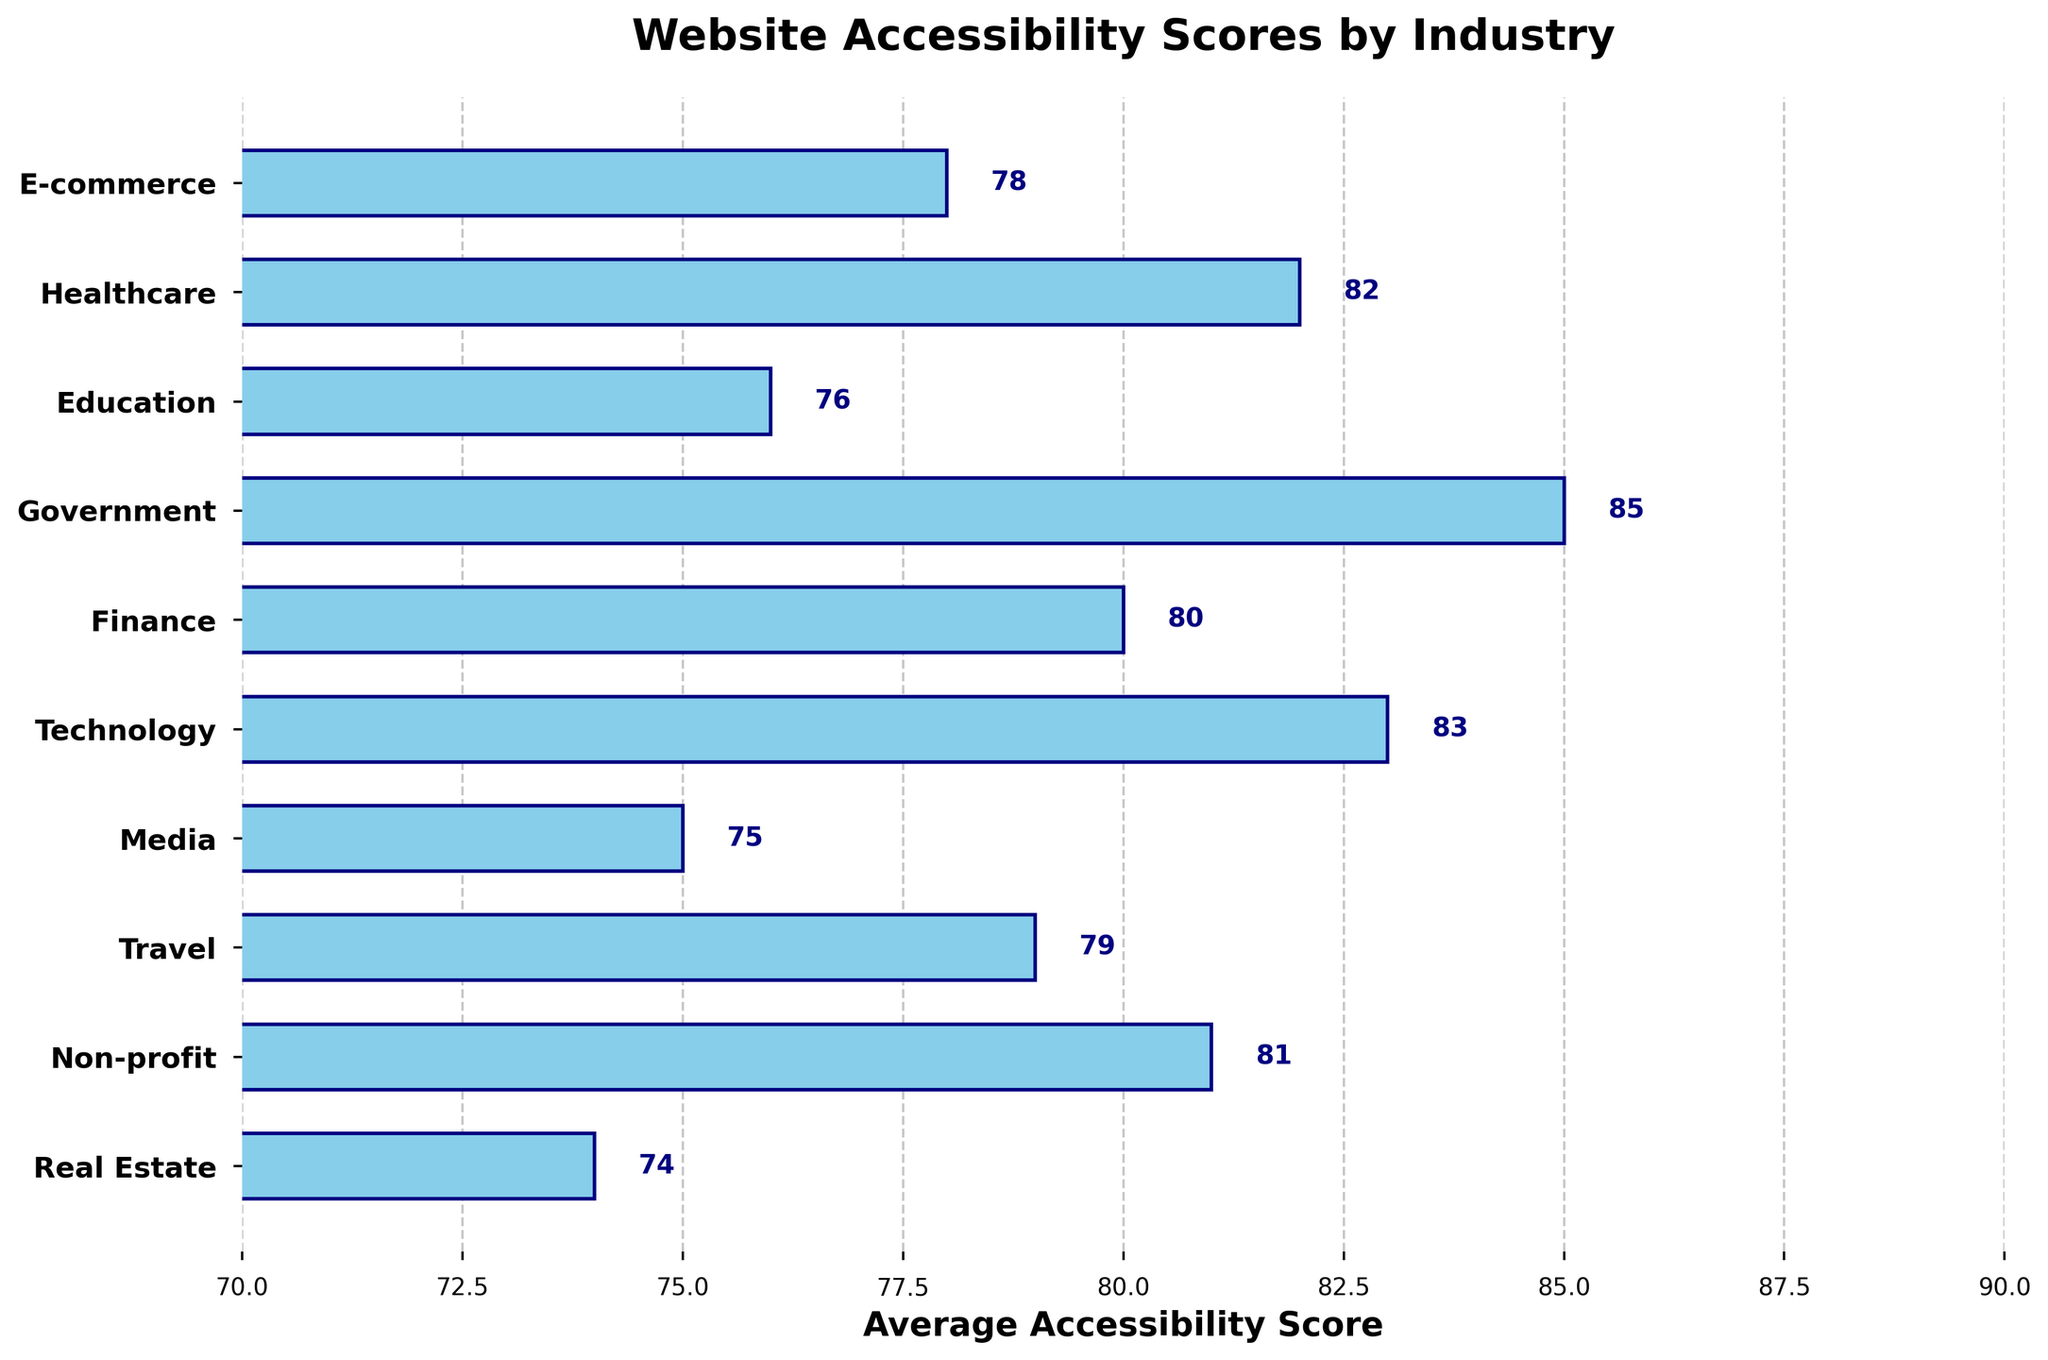What is the title of the figure? The title of the figure is usually located at the top of the chart. In this case, it reads "Website Accessibility Scores by Industry".
Answer: Website Accessibility Scores by Industry What is the average accessibility score for the Healthcare industry? Locate the Healthcare industry along the y-axis, then look at the bar corresponding to it. Next to or within the bar, you’ll see the score labeled as 82.
Answer: 82 Which industry has the highest average accessibility score? Look for the tallest bar along the horizontal axis, which is labeled 85. This bar corresponds to the Government industry.
Answer: Government How many industries have an average accessibility score of 80 or higher? Locate the bars with scores 80 or above by checking the numerical labels or bar lengths then count them. The industries are Healthcare (82), Finance (80), Technology (83), Travel (79), Non-profit (81), and Government (85). After checking again, it's clear that Travel was an oversight.
Answer: 5 What's the difference in the average accessibility score between the Technology and the Media industries? Locate the bars for Technology (83) and Media (75). Subtract the smaller value from the larger one to find the difference: 83 - 75 = 8.
Answer: 8 Which industry falls exactly in the middle of the range in terms of its average accessibility score? Order the industries by their scores: Government (85), Technology (83), Healthcare (82), Non-profit (81), Finance (80), Travel (79), E-commerce (78), Education (76), Media (75), Real Estate (74). The middle industry, i.e., 80)
Answer: Finance Is the average accessibility score for the Travel industry greater than that for the E-commerce industry? Compare the bars for Travel (79) and E-commerce (78). Since 79 is indeed greater than 78, the answer is yes.
Answer: Yes Which industry has the lowest average accessibility score? Identify the shortest bar along the horizontal axis, which is labeled 74. This bar corresponds to the Real Estate industry.
Answer: Real Estate What is the overall range of the average accessibility scores across all industries? Subtract the smallest value (74 for Real Estate) from the largest value (85 for Government): 85 - 74 = 11.
Answer: 11 